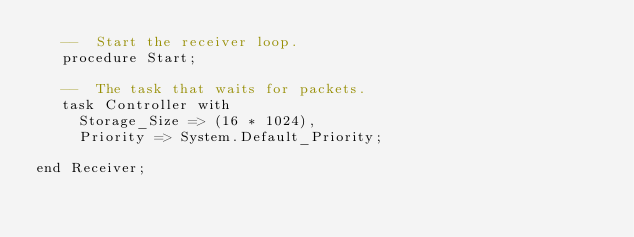Convert code to text. <code><loc_0><loc_0><loc_500><loc_500><_Ada_>   --  Start the receiver loop.
   procedure Start;

   --  The task that waits for packets.
   task Controller with
     Storage_Size => (16 * 1024),
     Priority => System.Default_Priority;

end Receiver;
</code> 